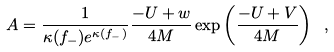Convert formula to latex. <formula><loc_0><loc_0><loc_500><loc_500>A = \frac { 1 } { \kappa ( f _ { - } ) e ^ { \kappa ( f _ { - } ) } } \frac { - U + w } { 4 M } \exp \left ( \frac { - U + V } { 4 M } \right ) \ ,</formula> 